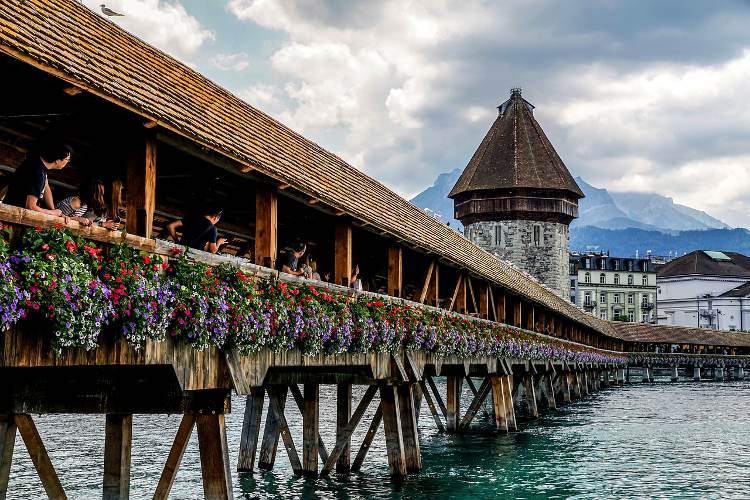What kind of activities can tourists enjoy around this bridge? Tourists visiting the Chapel Bridge in Lucerne can engage in numerous activities that enhance their experience of this historic site. One popular activity is walking across the bridge to admire its wooden structure and the beautiful paintings that depict Lucerne’s history and culture. Tourists can also visit the Water Tower, which houses local exhibitions and provides a unique view of the surrounding area. Additionally, the scenic riverside offers a perfect spot for taking photographs with the stunning backdrop of the Swiss Alps. Nearby cafes and restaurants allow visitors to enjoy Swiss cuisine, and guided tours offer in-depth historical insights. Boat cruises on Lake Lucerne provide a different perspective of the bridge and the city's breathtaking landscape. How would this bridge look during a festival? During a festival, the Chapel Bridge in Lucerne transforms into an even more vibrant and lively landmark. Decorative lights would illuminate the wooden structure at night, casting a magical glow over the river. The flower arrangements on the bridge would be even more elaborate, showcasing a riot of colors to celebrate the festive atmosphere. Musicians and street performers might entertain visitors with traditional Swiss music and dances, creating a joyous ambiance. Food stalls and souvenir vendors could line the nearby streets, offering local delicacies and handcrafted items. The festive air would be filled with the sounds of laughter and celebration, making the historic bridge a central hub of activity and enjoyment. 